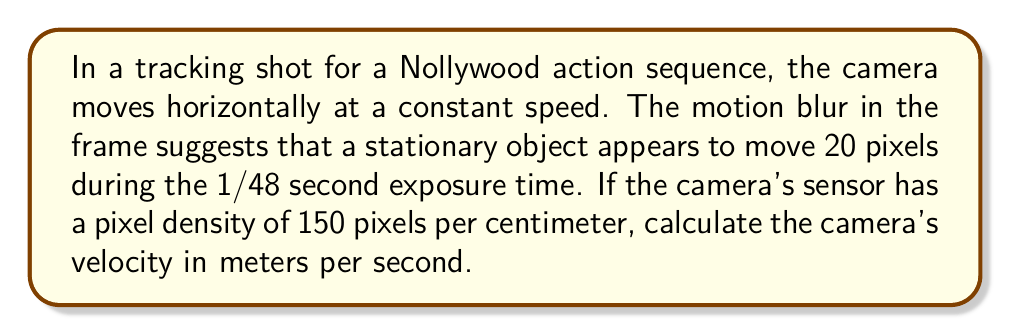Show me your answer to this math problem. To solve this problem, we'll follow these steps:

1) First, let's calculate the distance the camera moves during the exposure:
   $d = 20 \text{ pixels} \cdot \frac{1 \text{ cm}}{150 \text{ pixels}} = \frac{2}{15} \text{ cm} = 0.133 \text{ cm}$

2) We know that velocity is distance divided by time:
   $v = \frac{d}{t}$

3) We're given the time as 1/48 second, so let's plug in our values:
   $v = \frac{0.133 \text{ cm}}{\frac{1}{48} \text{ s}} = 0.133 \text{ cm} \cdot 48 \text{ s}^{-1} = 6.4 \text{ cm/s}$

4) Finally, we need to convert this to meters per second:
   $v = 6.4 \text{ cm/s} \cdot \frac{1 \text{ m}}{100 \text{ cm}} = 0.064 \text{ m/s}$

Therefore, the camera is moving at a velocity of 0.064 meters per second.
Answer: 0.064 m/s 